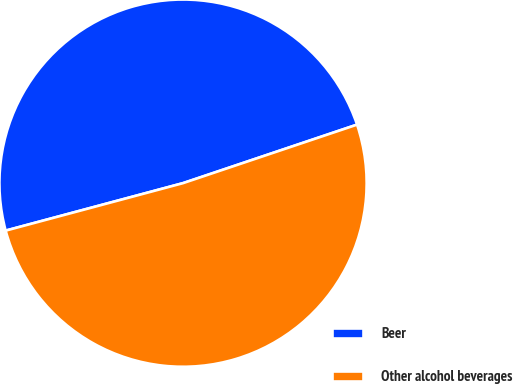Convert chart to OTSL. <chart><loc_0><loc_0><loc_500><loc_500><pie_chart><fcel>Beer<fcel>Other alcohol beverages<nl><fcel>49.0%<fcel>51.0%<nl></chart> 